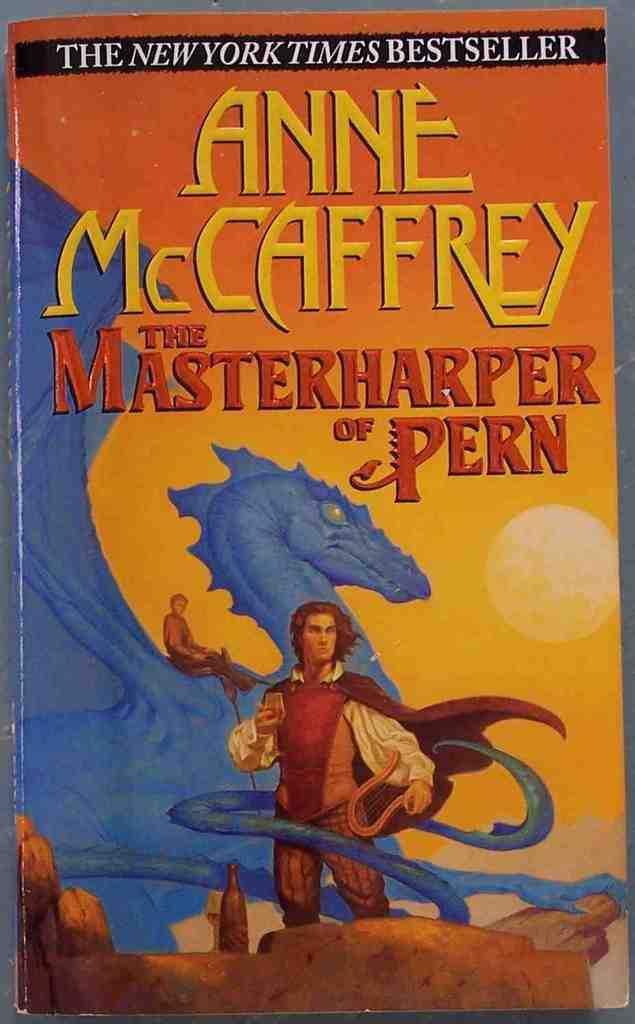Provide a one-sentence caption for the provided image. a book which is colofful called the masterharper of pern. 